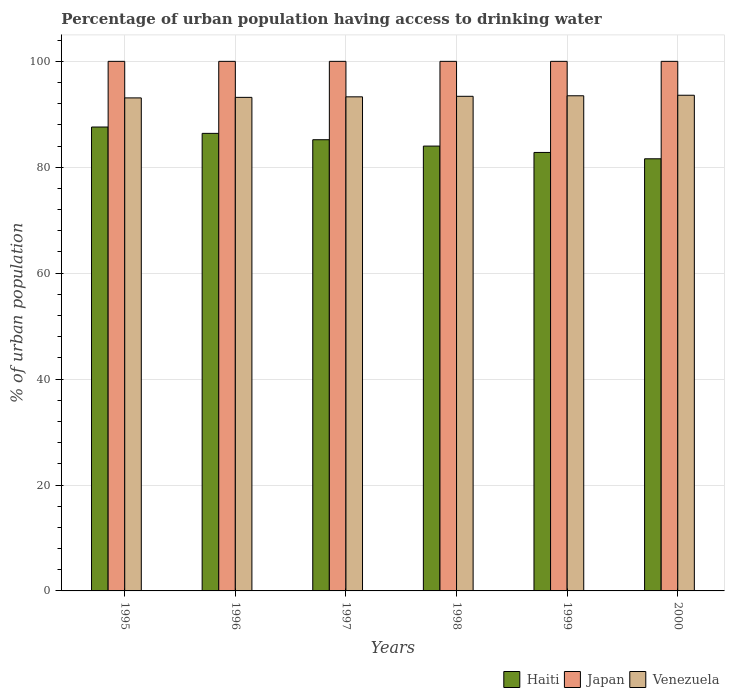Are the number of bars per tick equal to the number of legend labels?
Keep it short and to the point. Yes. How many bars are there on the 5th tick from the left?
Give a very brief answer. 3. What is the label of the 2nd group of bars from the left?
Your answer should be very brief. 1996. What is the percentage of urban population having access to drinking water in Venezuela in 1996?
Ensure brevity in your answer.  93.2. Across all years, what is the maximum percentage of urban population having access to drinking water in Venezuela?
Make the answer very short. 93.6. Across all years, what is the minimum percentage of urban population having access to drinking water in Japan?
Your answer should be very brief. 100. In which year was the percentage of urban population having access to drinking water in Venezuela maximum?
Provide a short and direct response. 2000. In which year was the percentage of urban population having access to drinking water in Japan minimum?
Make the answer very short. 1995. What is the total percentage of urban population having access to drinking water in Venezuela in the graph?
Your answer should be compact. 560.1. What is the difference between the percentage of urban population having access to drinking water in Venezuela in 1997 and that in 1999?
Give a very brief answer. -0.2. What is the difference between the percentage of urban population having access to drinking water in Venezuela in 2000 and the percentage of urban population having access to drinking water in Haiti in 1999?
Provide a succinct answer. 10.8. What is the average percentage of urban population having access to drinking water in Haiti per year?
Your answer should be very brief. 84.6. In the year 1997, what is the difference between the percentage of urban population having access to drinking water in Haiti and percentage of urban population having access to drinking water in Venezuela?
Give a very brief answer. -8.1. What is the ratio of the percentage of urban population having access to drinking water in Venezuela in 1995 to that in 2000?
Your answer should be very brief. 0.99. Is the difference between the percentage of urban population having access to drinking water in Haiti in 1996 and 1998 greater than the difference between the percentage of urban population having access to drinking water in Venezuela in 1996 and 1998?
Offer a terse response. Yes. What is the difference between the highest and the second highest percentage of urban population having access to drinking water in Japan?
Make the answer very short. 0. What is the difference between the highest and the lowest percentage of urban population having access to drinking water in Haiti?
Keep it short and to the point. 6. In how many years, is the percentage of urban population having access to drinking water in Venezuela greater than the average percentage of urban population having access to drinking water in Venezuela taken over all years?
Offer a very short reply. 3. Is the sum of the percentage of urban population having access to drinking water in Venezuela in 1997 and 1998 greater than the maximum percentage of urban population having access to drinking water in Japan across all years?
Your answer should be very brief. Yes. What does the 2nd bar from the right in 1996 represents?
Ensure brevity in your answer.  Japan. Is it the case that in every year, the sum of the percentage of urban population having access to drinking water in Japan and percentage of urban population having access to drinking water in Haiti is greater than the percentage of urban population having access to drinking water in Venezuela?
Ensure brevity in your answer.  Yes. How many years are there in the graph?
Your answer should be compact. 6. What is the difference between two consecutive major ticks on the Y-axis?
Your response must be concise. 20. Are the values on the major ticks of Y-axis written in scientific E-notation?
Keep it short and to the point. No. Does the graph contain any zero values?
Provide a short and direct response. No. Where does the legend appear in the graph?
Provide a succinct answer. Bottom right. How many legend labels are there?
Provide a succinct answer. 3. What is the title of the graph?
Your answer should be compact. Percentage of urban population having access to drinking water. What is the label or title of the Y-axis?
Give a very brief answer. % of urban population. What is the % of urban population of Haiti in 1995?
Provide a short and direct response. 87.6. What is the % of urban population of Japan in 1995?
Offer a very short reply. 100. What is the % of urban population of Venezuela in 1995?
Keep it short and to the point. 93.1. What is the % of urban population of Haiti in 1996?
Your answer should be very brief. 86.4. What is the % of urban population of Japan in 1996?
Offer a terse response. 100. What is the % of urban population in Venezuela in 1996?
Keep it short and to the point. 93.2. What is the % of urban population in Haiti in 1997?
Your answer should be very brief. 85.2. What is the % of urban population in Japan in 1997?
Ensure brevity in your answer.  100. What is the % of urban population in Venezuela in 1997?
Your response must be concise. 93.3. What is the % of urban population of Venezuela in 1998?
Make the answer very short. 93.4. What is the % of urban population in Haiti in 1999?
Your answer should be very brief. 82.8. What is the % of urban population of Japan in 1999?
Keep it short and to the point. 100. What is the % of urban population in Venezuela in 1999?
Ensure brevity in your answer.  93.5. What is the % of urban population of Haiti in 2000?
Your answer should be compact. 81.6. What is the % of urban population of Venezuela in 2000?
Make the answer very short. 93.6. Across all years, what is the maximum % of urban population in Haiti?
Give a very brief answer. 87.6. Across all years, what is the maximum % of urban population of Japan?
Give a very brief answer. 100. Across all years, what is the maximum % of urban population of Venezuela?
Your answer should be very brief. 93.6. Across all years, what is the minimum % of urban population of Haiti?
Keep it short and to the point. 81.6. Across all years, what is the minimum % of urban population in Venezuela?
Offer a terse response. 93.1. What is the total % of urban population of Haiti in the graph?
Your response must be concise. 507.6. What is the total % of urban population in Japan in the graph?
Provide a succinct answer. 600. What is the total % of urban population in Venezuela in the graph?
Ensure brevity in your answer.  560.1. What is the difference between the % of urban population of Venezuela in 1995 and that in 1997?
Provide a short and direct response. -0.2. What is the difference between the % of urban population in Japan in 1995 and that in 1998?
Your answer should be compact. 0. What is the difference between the % of urban population in Venezuela in 1995 and that in 1998?
Provide a short and direct response. -0.3. What is the difference between the % of urban population in Venezuela in 1995 and that in 1999?
Make the answer very short. -0.4. What is the difference between the % of urban population in Haiti in 1996 and that in 1998?
Ensure brevity in your answer.  2.4. What is the difference between the % of urban population of Japan in 1996 and that in 1998?
Offer a very short reply. 0. What is the difference between the % of urban population of Venezuela in 1996 and that in 1998?
Keep it short and to the point. -0.2. What is the difference between the % of urban population in Haiti in 1996 and that in 1999?
Offer a very short reply. 3.6. What is the difference between the % of urban population in Venezuela in 1996 and that in 1999?
Keep it short and to the point. -0.3. What is the difference between the % of urban population in Haiti in 1996 and that in 2000?
Your answer should be very brief. 4.8. What is the difference between the % of urban population in Japan in 1996 and that in 2000?
Offer a very short reply. 0. What is the difference between the % of urban population of Venezuela in 1996 and that in 2000?
Offer a very short reply. -0.4. What is the difference between the % of urban population of Haiti in 1997 and that in 1998?
Your answer should be compact. 1.2. What is the difference between the % of urban population of Japan in 1997 and that in 1998?
Provide a succinct answer. 0. What is the difference between the % of urban population of Venezuela in 1997 and that in 1998?
Keep it short and to the point. -0.1. What is the difference between the % of urban population of Haiti in 1997 and that in 1999?
Offer a very short reply. 2.4. What is the difference between the % of urban population in Japan in 1997 and that in 1999?
Offer a very short reply. 0. What is the difference between the % of urban population of Venezuela in 1997 and that in 1999?
Provide a succinct answer. -0.2. What is the difference between the % of urban population in Japan in 1997 and that in 2000?
Your answer should be compact. 0. What is the difference between the % of urban population of Venezuela in 1997 and that in 2000?
Provide a succinct answer. -0.3. What is the difference between the % of urban population in Haiti in 1998 and that in 1999?
Keep it short and to the point. 1.2. What is the difference between the % of urban population of Venezuela in 1998 and that in 1999?
Your answer should be very brief. -0.1. What is the difference between the % of urban population in Venezuela in 1998 and that in 2000?
Give a very brief answer. -0.2. What is the difference between the % of urban population in Haiti in 1999 and that in 2000?
Your answer should be compact. 1.2. What is the difference between the % of urban population of Japan in 1999 and that in 2000?
Your answer should be compact. 0. What is the difference between the % of urban population of Haiti in 1995 and the % of urban population of Venezuela in 1996?
Provide a short and direct response. -5.6. What is the difference between the % of urban population in Haiti in 1995 and the % of urban population in Japan in 1997?
Your answer should be compact. -12.4. What is the difference between the % of urban population of Haiti in 1995 and the % of urban population of Venezuela in 1997?
Give a very brief answer. -5.7. What is the difference between the % of urban population in Haiti in 1995 and the % of urban population in Japan in 1998?
Provide a succinct answer. -12.4. What is the difference between the % of urban population in Japan in 1995 and the % of urban population in Venezuela in 1998?
Offer a very short reply. 6.6. What is the difference between the % of urban population of Haiti in 1995 and the % of urban population of Venezuela in 1999?
Offer a terse response. -5.9. What is the difference between the % of urban population in Japan in 1995 and the % of urban population in Venezuela in 1999?
Give a very brief answer. 6.5. What is the difference between the % of urban population in Haiti in 1995 and the % of urban population in Japan in 2000?
Offer a very short reply. -12.4. What is the difference between the % of urban population of Haiti in 1995 and the % of urban population of Venezuela in 2000?
Your answer should be very brief. -6. What is the difference between the % of urban population of Japan in 1995 and the % of urban population of Venezuela in 2000?
Provide a succinct answer. 6.4. What is the difference between the % of urban population of Haiti in 1996 and the % of urban population of Japan in 1997?
Ensure brevity in your answer.  -13.6. What is the difference between the % of urban population in Haiti in 1996 and the % of urban population in Venezuela in 1997?
Offer a terse response. -6.9. What is the difference between the % of urban population of Japan in 1996 and the % of urban population of Venezuela in 1997?
Your answer should be very brief. 6.7. What is the difference between the % of urban population in Haiti in 1996 and the % of urban population in Japan in 1998?
Ensure brevity in your answer.  -13.6. What is the difference between the % of urban population in Japan in 1996 and the % of urban population in Venezuela in 1998?
Your answer should be compact. 6.6. What is the difference between the % of urban population of Japan in 1996 and the % of urban population of Venezuela in 1999?
Keep it short and to the point. 6.5. What is the difference between the % of urban population in Haiti in 1996 and the % of urban population in Japan in 2000?
Provide a succinct answer. -13.6. What is the difference between the % of urban population in Haiti in 1996 and the % of urban population in Venezuela in 2000?
Give a very brief answer. -7.2. What is the difference between the % of urban population in Haiti in 1997 and the % of urban population in Japan in 1998?
Offer a terse response. -14.8. What is the difference between the % of urban population in Haiti in 1997 and the % of urban population in Japan in 1999?
Provide a succinct answer. -14.8. What is the difference between the % of urban population of Haiti in 1997 and the % of urban population of Venezuela in 1999?
Your response must be concise. -8.3. What is the difference between the % of urban population in Japan in 1997 and the % of urban population in Venezuela in 1999?
Offer a very short reply. 6.5. What is the difference between the % of urban population in Haiti in 1997 and the % of urban population in Japan in 2000?
Provide a succinct answer. -14.8. What is the difference between the % of urban population in Haiti in 1998 and the % of urban population in Japan in 1999?
Give a very brief answer. -16. What is the difference between the % of urban population in Haiti in 1999 and the % of urban population in Japan in 2000?
Offer a terse response. -17.2. What is the difference between the % of urban population of Haiti in 1999 and the % of urban population of Venezuela in 2000?
Offer a very short reply. -10.8. What is the difference between the % of urban population in Japan in 1999 and the % of urban population in Venezuela in 2000?
Your response must be concise. 6.4. What is the average % of urban population in Haiti per year?
Provide a succinct answer. 84.6. What is the average % of urban population in Japan per year?
Make the answer very short. 100. What is the average % of urban population in Venezuela per year?
Ensure brevity in your answer.  93.35. In the year 1995, what is the difference between the % of urban population of Haiti and % of urban population of Japan?
Provide a succinct answer. -12.4. In the year 1995, what is the difference between the % of urban population of Japan and % of urban population of Venezuela?
Offer a terse response. 6.9. In the year 1996, what is the difference between the % of urban population of Haiti and % of urban population of Japan?
Provide a succinct answer. -13.6. In the year 1996, what is the difference between the % of urban population in Haiti and % of urban population in Venezuela?
Your response must be concise. -6.8. In the year 1997, what is the difference between the % of urban population of Haiti and % of urban population of Japan?
Give a very brief answer. -14.8. In the year 1997, what is the difference between the % of urban population in Haiti and % of urban population in Venezuela?
Offer a very short reply. -8.1. In the year 1998, what is the difference between the % of urban population of Haiti and % of urban population of Japan?
Make the answer very short. -16. In the year 1998, what is the difference between the % of urban population in Haiti and % of urban population in Venezuela?
Make the answer very short. -9.4. In the year 1999, what is the difference between the % of urban population of Haiti and % of urban population of Japan?
Your answer should be compact. -17.2. In the year 1999, what is the difference between the % of urban population in Haiti and % of urban population in Venezuela?
Offer a very short reply. -10.7. In the year 1999, what is the difference between the % of urban population in Japan and % of urban population in Venezuela?
Provide a succinct answer. 6.5. In the year 2000, what is the difference between the % of urban population in Haiti and % of urban population in Japan?
Provide a succinct answer. -18.4. What is the ratio of the % of urban population in Haiti in 1995 to that in 1996?
Provide a succinct answer. 1.01. What is the ratio of the % of urban population of Venezuela in 1995 to that in 1996?
Keep it short and to the point. 1. What is the ratio of the % of urban population of Haiti in 1995 to that in 1997?
Make the answer very short. 1.03. What is the ratio of the % of urban population in Venezuela in 1995 to that in 1997?
Your answer should be compact. 1. What is the ratio of the % of urban population of Haiti in 1995 to that in 1998?
Keep it short and to the point. 1.04. What is the ratio of the % of urban population of Japan in 1995 to that in 1998?
Your response must be concise. 1. What is the ratio of the % of urban population of Haiti in 1995 to that in 1999?
Offer a terse response. 1.06. What is the ratio of the % of urban population in Haiti in 1995 to that in 2000?
Give a very brief answer. 1.07. What is the ratio of the % of urban population in Japan in 1995 to that in 2000?
Offer a terse response. 1. What is the ratio of the % of urban population in Venezuela in 1995 to that in 2000?
Make the answer very short. 0.99. What is the ratio of the % of urban population in Haiti in 1996 to that in 1997?
Give a very brief answer. 1.01. What is the ratio of the % of urban population in Haiti in 1996 to that in 1998?
Offer a terse response. 1.03. What is the ratio of the % of urban population of Haiti in 1996 to that in 1999?
Provide a succinct answer. 1.04. What is the ratio of the % of urban population of Japan in 1996 to that in 1999?
Offer a terse response. 1. What is the ratio of the % of urban population of Haiti in 1996 to that in 2000?
Give a very brief answer. 1.06. What is the ratio of the % of urban population of Japan in 1996 to that in 2000?
Provide a short and direct response. 1. What is the ratio of the % of urban population in Haiti in 1997 to that in 1998?
Make the answer very short. 1.01. What is the ratio of the % of urban population in Venezuela in 1997 to that in 1998?
Keep it short and to the point. 1. What is the ratio of the % of urban population of Haiti in 1997 to that in 1999?
Your answer should be very brief. 1.03. What is the ratio of the % of urban population in Japan in 1997 to that in 1999?
Make the answer very short. 1. What is the ratio of the % of urban population in Haiti in 1997 to that in 2000?
Offer a terse response. 1.04. What is the ratio of the % of urban population in Japan in 1997 to that in 2000?
Provide a succinct answer. 1. What is the ratio of the % of urban population in Haiti in 1998 to that in 1999?
Provide a short and direct response. 1.01. What is the ratio of the % of urban population of Japan in 1998 to that in 1999?
Offer a very short reply. 1. What is the ratio of the % of urban population of Haiti in 1998 to that in 2000?
Your answer should be compact. 1.03. What is the ratio of the % of urban population in Japan in 1998 to that in 2000?
Give a very brief answer. 1. What is the ratio of the % of urban population in Haiti in 1999 to that in 2000?
Offer a terse response. 1.01. What is the ratio of the % of urban population in Japan in 1999 to that in 2000?
Your response must be concise. 1. What is the ratio of the % of urban population in Venezuela in 1999 to that in 2000?
Offer a terse response. 1. What is the difference between the highest and the second highest % of urban population in Haiti?
Your answer should be compact. 1.2. What is the difference between the highest and the second highest % of urban population of Japan?
Ensure brevity in your answer.  0. What is the difference between the highest and the second highest % of urban population in Venezuela?
Make the answer very short. 0.1. What is the difference between the highest and the lowest % of urban population of Japan?
Keep it short and to the point. 0. 